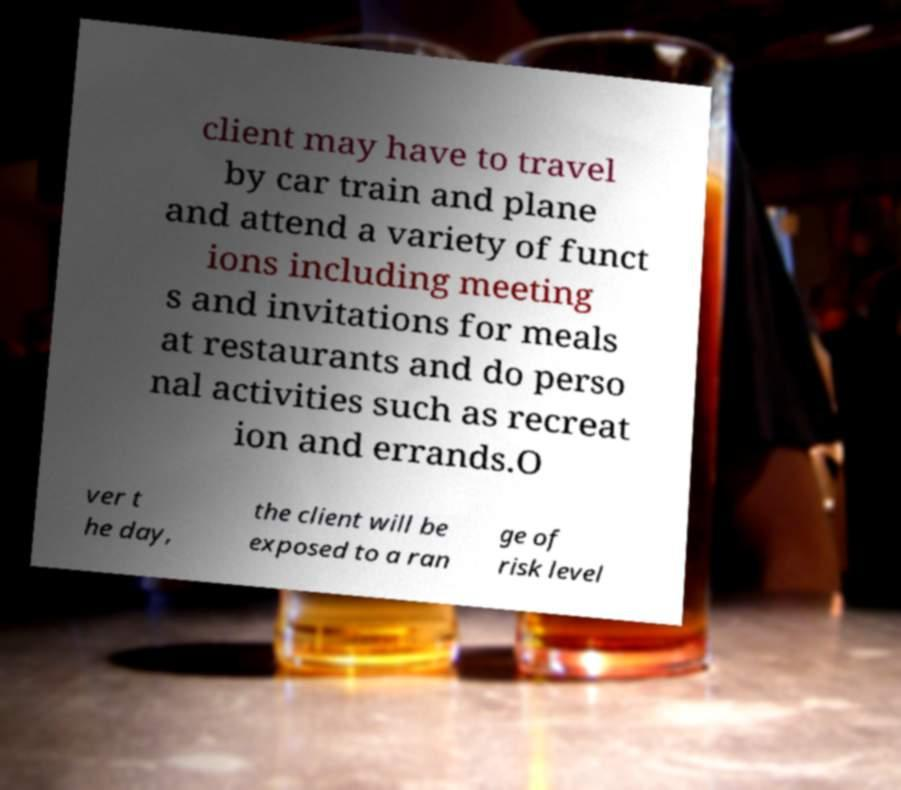Could you extract and type out the text from this image? client may have to travel by car train and plane and attend a variety of funct ions including meeting s and invitations for meals at restaurants and do perso nal activities such as recreat ion and errands.O ver t he day, the client will be exposed to a ran ge of risk level 